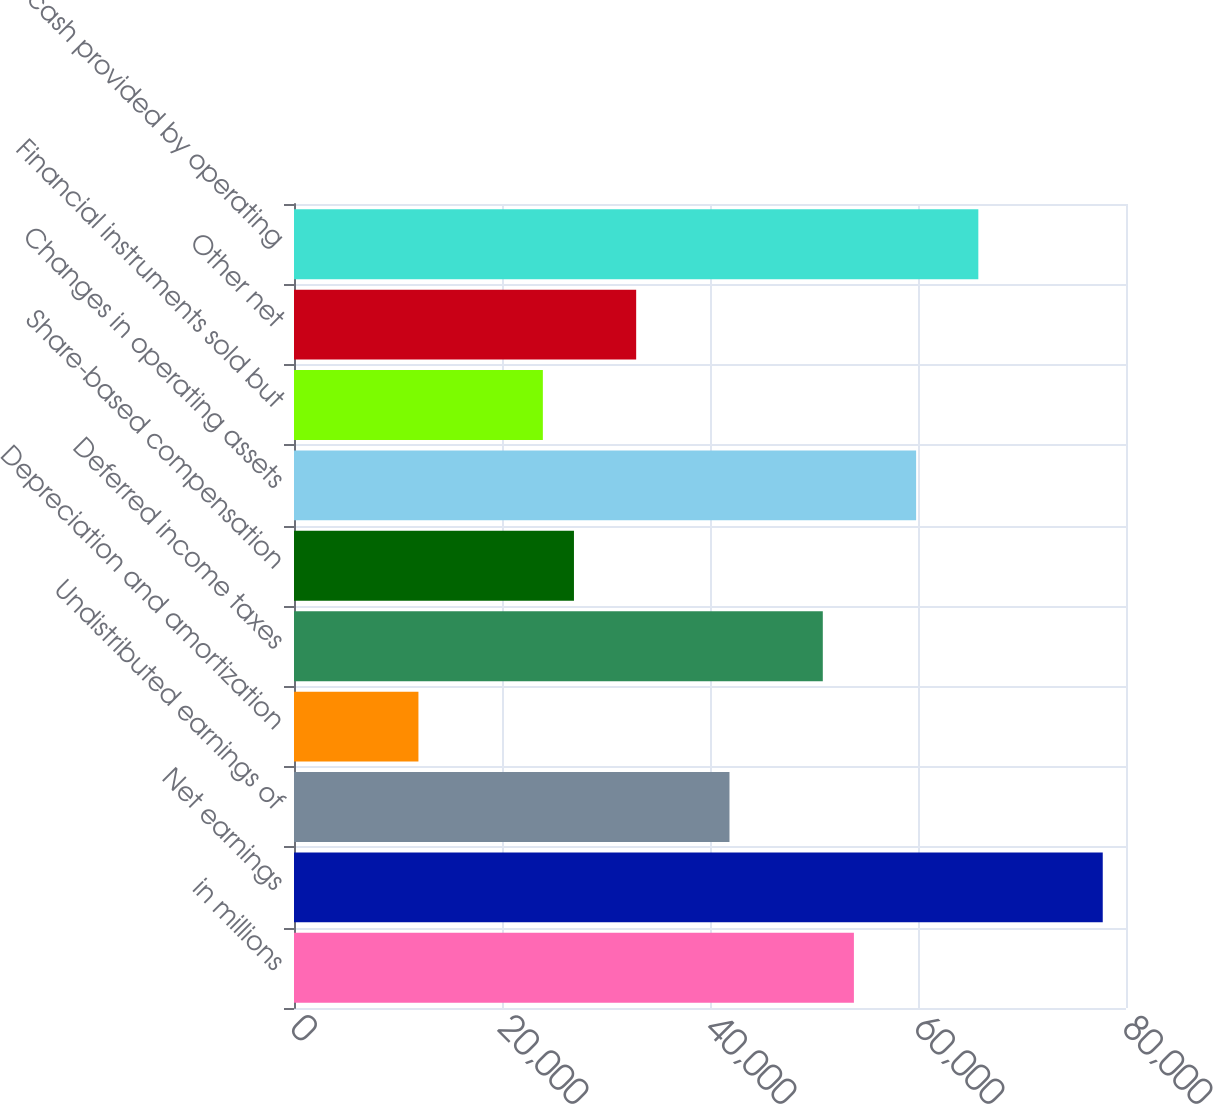<chart> <loc_0><loc_0><loc_500><loc_500><bar_chart><fcel>in millions<fcel>Net earnings<fcel>Undistributed earnings of<fcel>Depreciation and amortization<fcel>Deferred income taxes<fcel>Share-based compensation<fcel>Changes in operating assets<fcel>Financial instruments sold but<fcel>Other net<fcel>Net cash provided by operating<nl><fcel>53837.2<fcel>77764.4<fcel>41873.6<fcel>11964.6<fcel>50846.3<fcel>26919.1<fcel>59819<fcel>23928.2<fcel>32900.9<fcel>65800.8<nl></chart> 